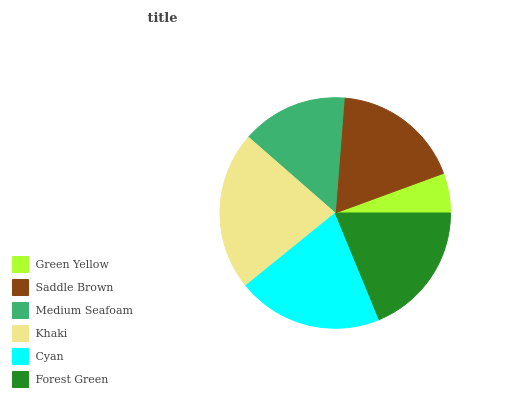Is Green Yellow the minimum?
Answer yes or no. Yes. Is Khaki the maximum?
Answer yes or no. Yes. Is Saddle Brown the minimum?
Answer yes or no. No. Is Saddle Brown the maximum?
Answer yes or no. No. Is Saddle Brown greater than Green Yellow?
Answer yes or no. Yes. Is Green Yellow less than Saddle Brown?
Answer yes or no. Yes. Is Green Yellow greater than Saddle Brown?
Answer yes or no. No. Is Saddle Brown less than Green Yellow?
Answer yes or no. No. Is Forest Green the high median?
Answer yes or no. Yes. Is Saddle Brown the low median?
Answer yes or no. Yes. Is Saddle Brown the high median?
Answer yes or no. No. Is Forest Green the low median?
Answer yes or no. No. 